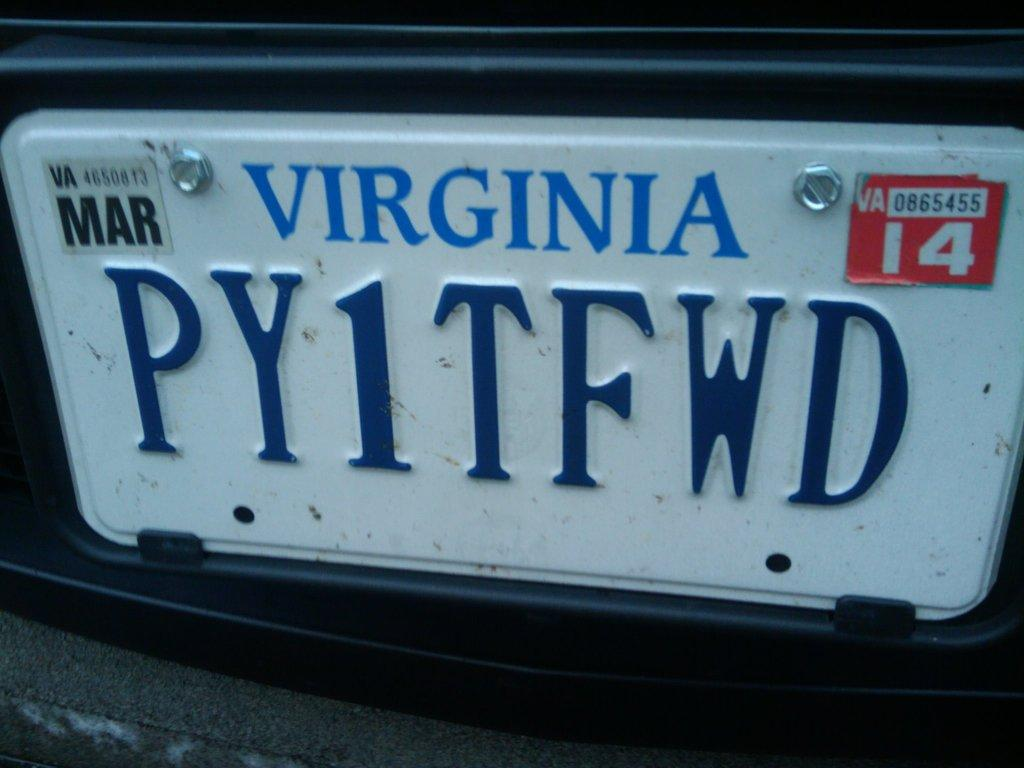<image>
Offer a succinct explanation of the picture presented. A close up of a Viriginia licence plate PY1TFWD 